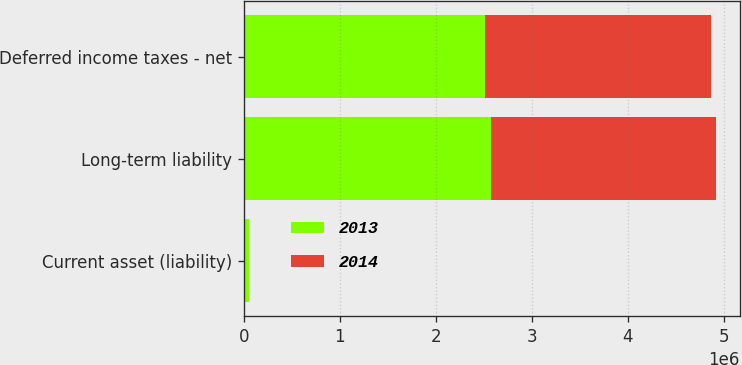Convert chart to OTSL. <chart><loc_0><loc_0><loc_500><loc_500><stacked_bar_chart><ecel><fcel>Current asset (liability)<fcel>Long-term liability<fcel>Deferred income taxes - net<nl><fcel>2013<fcel>55253<fcel>2.57136e+06<fcel>2.51611e+06<nl><fcel>2014<fcel>2033<fcel>2.34772e+06<fcel>2.34976e+06<nl></chart> 